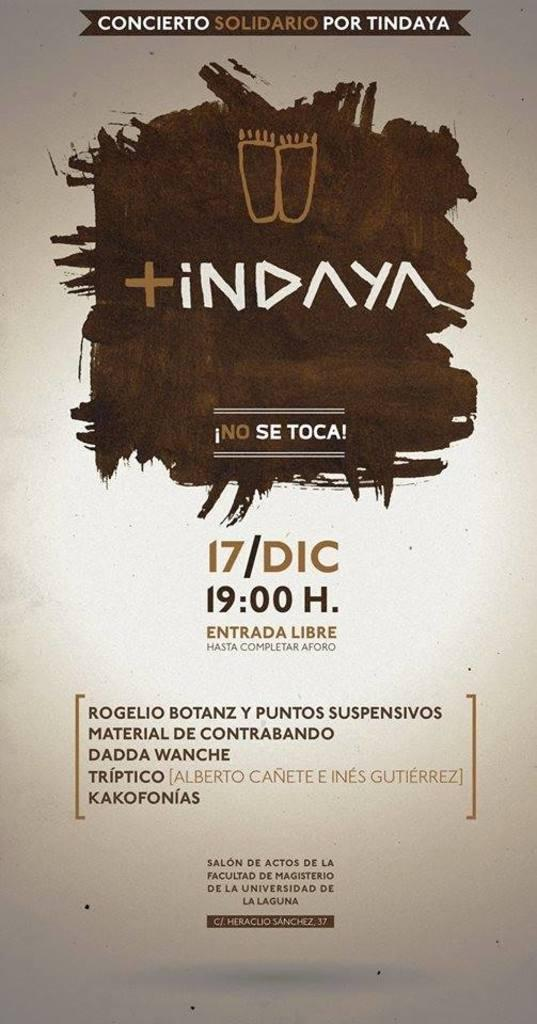<image>
Create a compact narrative representing the image presented. A mostly white poster with a brown square that is advertising Indaya. 